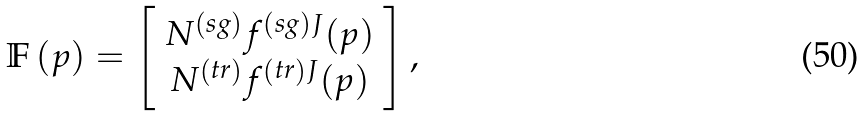<formula> <loc_0><loc_0><loc_500><loc_500>\mathbb { F } \left ( p \right ) = \left [ \begin{array} { c } N ^ { \left ( s g \right ) } f ^ { \left ( s g \right ) J } ( p ) \\ N ^ { \left ( t r \right ) } f ^ { \left ( t r \right ) J } ( p ) \end{array} \right ] ,</formula> 